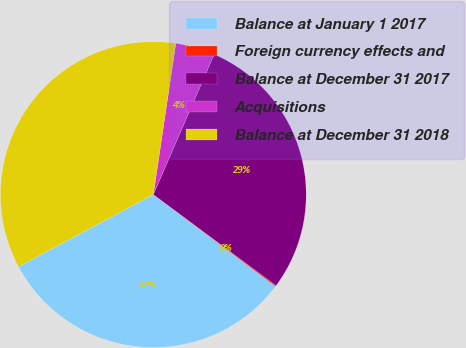Convert chart. <chart><loc_0><loc_0><loc_500><loc_500><pie_chart><fcel>Balance at January 1 2017<fcel>Foreign currency effects and<fcel>Balance at December 31 2017<fcel>Acquisitions<fcel>Balance at December 31 2018<nl><fcel>31.91%<fcel>0.11%<fcel>28.64%<fcel>4.17%<fcel>35.18%<nl></chart> 